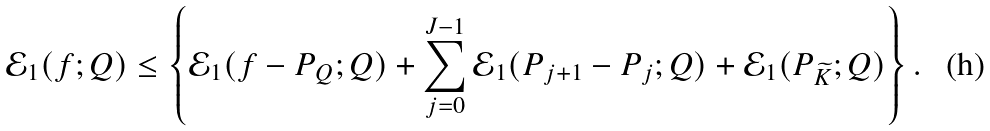Convert formula to latex. <formula><loc_0><loc_0><loc_500><loc_500>\mathcal { E } _ { 1 } ( f ; Q ) \leq \left \{ \mathcal { E } _ { 1 } ( f - P _ { Q } ; Q ) + \sum _ { j = 0 } ^ { J - 1 } \mathcal { E } _ { 1 } ( P _ { j + 1 } - P _ { j } ; Q ) + \mathcal { E } _ { 1 } ( P _ { \widetilde { K } } ; Q ) \right \} .</formula> 